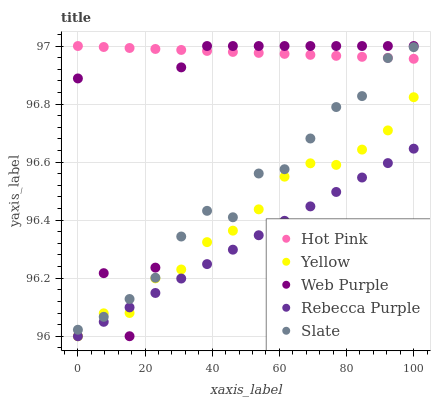Does Rebecca Purple have the minimum area under the curve?
Answer yes or no. Yes. Does Hot Pink have the maximum area under the curve?
Answer yes or no. Yes. Does Web Purple have the minimum area under the curve?
Answer yes or no. No. Does Web Purple have the maximum area under the curve?
Answer yes or no. No. Is Rebecca Purple the smoothest?
Answer yes or no. Yes. Is Web Purple the roughest?
Answer yes or no. Yes. Is Hot Pink the smoothest?
Answer yes or no. No. Is Hot Pink the roughest?
Answer yes or no. No. Does Rebecca Purple have the lowest value?
Answer yes or no. Yes. Does Web Purple have the lowest value?
Answer yes or no. No. Does Hot Pink have the highest value?
Answer yes or no. Yes. Does Rebecca Purple have the highest value?
Answer yes or no. No. Is Yellow less than Hot Pink?
Answer yes or no. Yes. Is Hot Pink greater than Yellow?
Answer yes or no. Yes. Does Web Purple intersect Yellow?
Answer yes or no. Yes. Is Web Purple less than Yellow?
Answer yes or no. No. Is Web Purple greater than Yellow?
Answer yes or no. No. Does Yellow intersect Hot Pink?
Answer yes or no. No. 